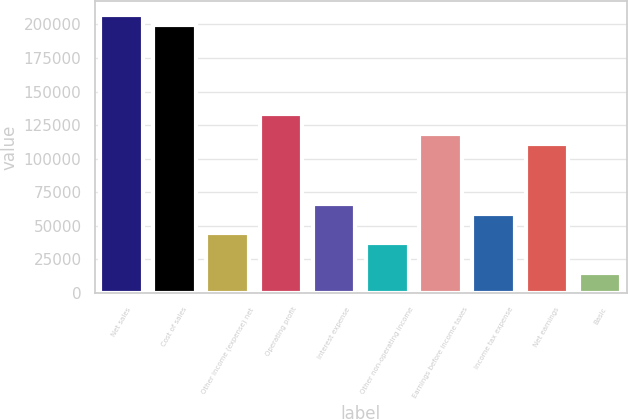Convert chart. <chart><loc_0><loc_0><loc_500><loc_500><bar_chart><fcel>Net sales<fcel>Cost of sales<fcel>Other income (expense) net<fcel>Operating profit<fcel>Interest expense<fcel>Other non-operating income<fcel>Earnings before income taxes<fcel>Income tax expense<fcel>Net earnings<fcel>Basic<nl><fcel>207159<fcel>199761<fcel>44392<fcel>133174<fcel>66587.5<fcel>36993.5<fcel>118377<fcel>59189<fcel>110979<fcel>14797.9<nl></chart> 